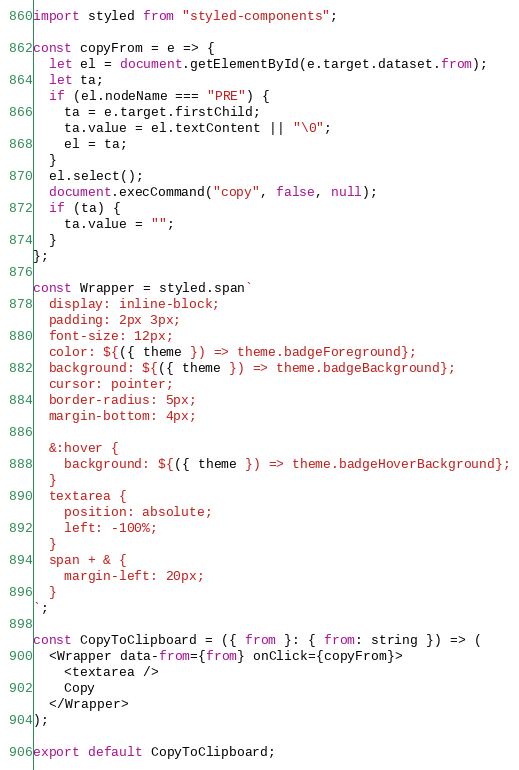Convert code to text. <code><loc_0><loc_0><loc_500><loc_500><_JavaScript_>import styled from "styled-components";

const copyFrom = e => {
  let el = document.getElementById(e.target.dataset.from);
  let ta;
  if (el.nodeName === "PRE") {
    ta = e.target.firstChild;
    ta.value = el.textContent || "\0";
    el = ta;
  }
  el.select();
  document.execCommand("copy", false, null);
  if (ta) {
    ta.value = "";
  }
};

const Wrapper = styled.span`
  display: inline-block;
  padding: 2px 3px;
  font-size: 12px;
  color: ${({ theme }) => theme.badgeForeground};
  background: ${({ theme }) => theme.badgeBackground};
  cursor: pointer;
  border-radius: 5px;
  margin-bottom: 4px;

  &:hover {
    background: ${({ theme }) => theme.badgeHoverBackground};
  }
  textarea {
    position: absolute;
    left: -100%;
  }
  span + & {
    margin-left: 20px;
  }
`;

const CopyToClipboard = ({ from }: { from: string }) => (
  <Wrapper data-from={from} onClick={copyFrom}>
    <textarea />
    Copy
  </Wrapper>
);

export default CopyToClipboard;
</code> 